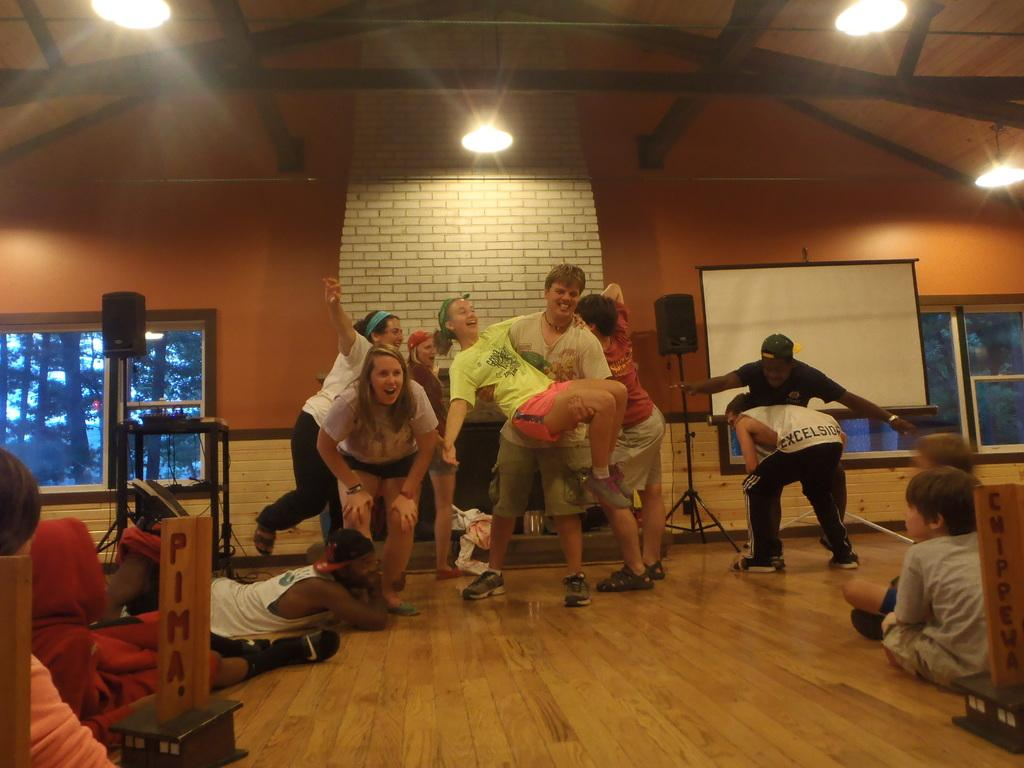Provide a one-sentence caption for the provided image. People playing next to a sign that is cut off saying Pima. 